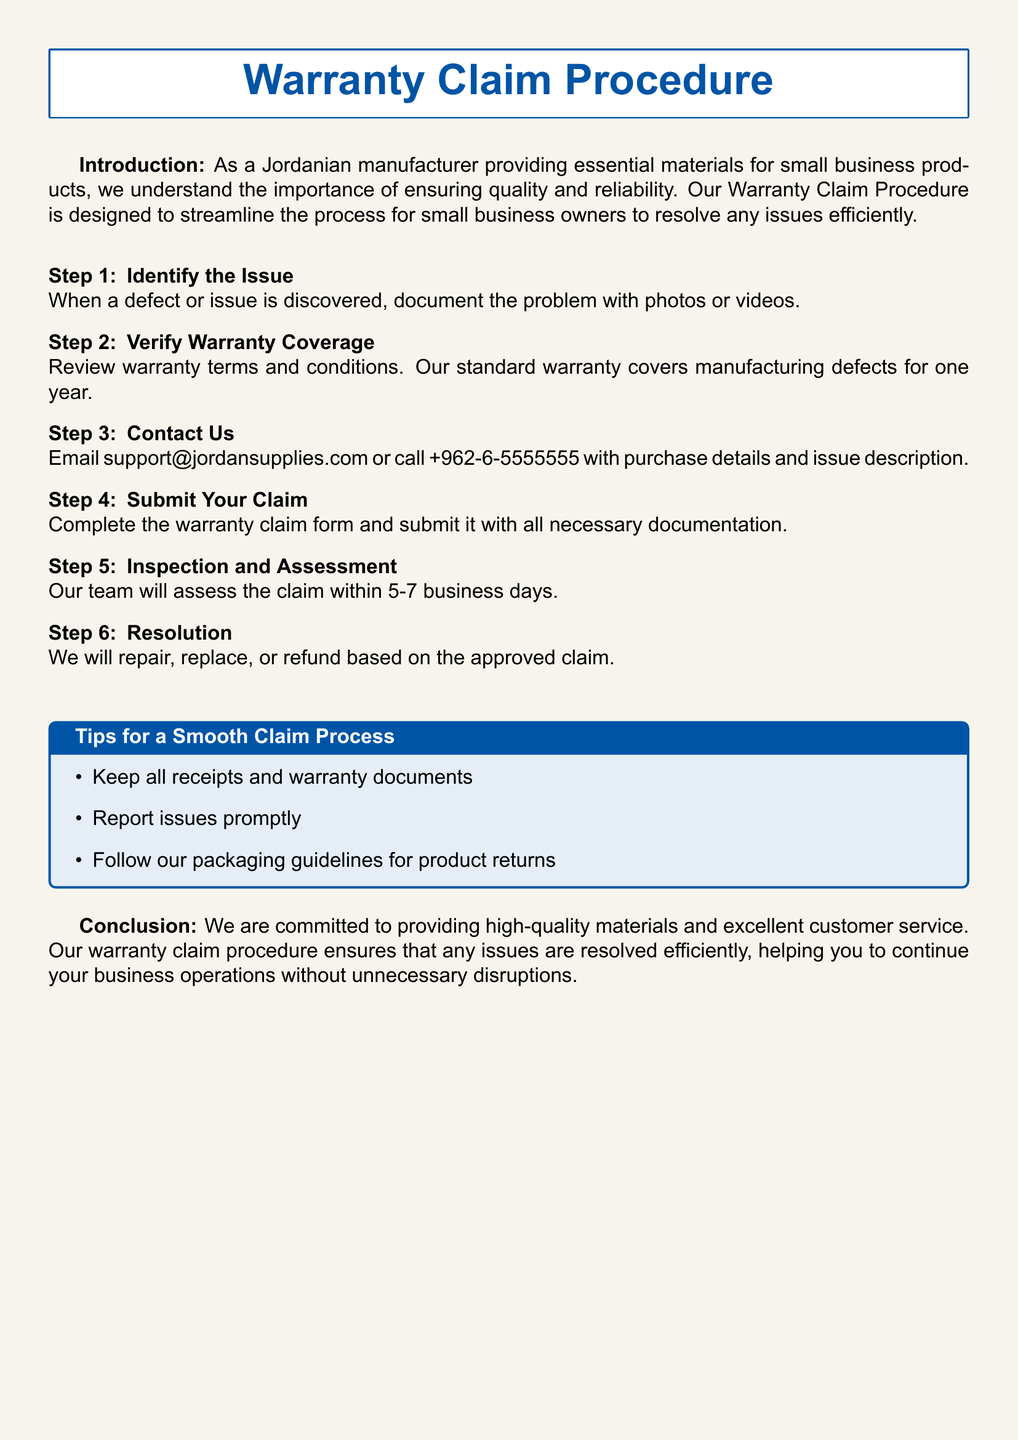What is the warranty period? The standard warranty covers manufacturing defects for one year.
Answer: one year How can I contact support? The document provides an email and a phone number for contacting support regarding warranty claims.
Answer: support@jordansupplies.com What is the first step in the warranty claim procedure? The first step involves identifying the issue and documenting the problem.
Answer: Identify the Issue How long will the assessment take? The document specifies the assessment period for claims.
Answer: 5-7 business days What should I keep for a smooth claim process? The tips section emphasizes the importance of keeping certain documents for the warranty claim process.
Answer: all receipts and warranty documents What is the last step in the claim procedure? The last step outlines the possible resolutions based on the claim assessment.
Answer: Resolution What should I do immediately after discovering a defect? The first step advises documenting the problem with photos or videos.
Answer: document the problem What type of defects does the warranty cover? The warranty explicitly includes a specific type of defect that is covered.
Answer: manufacturing defects 